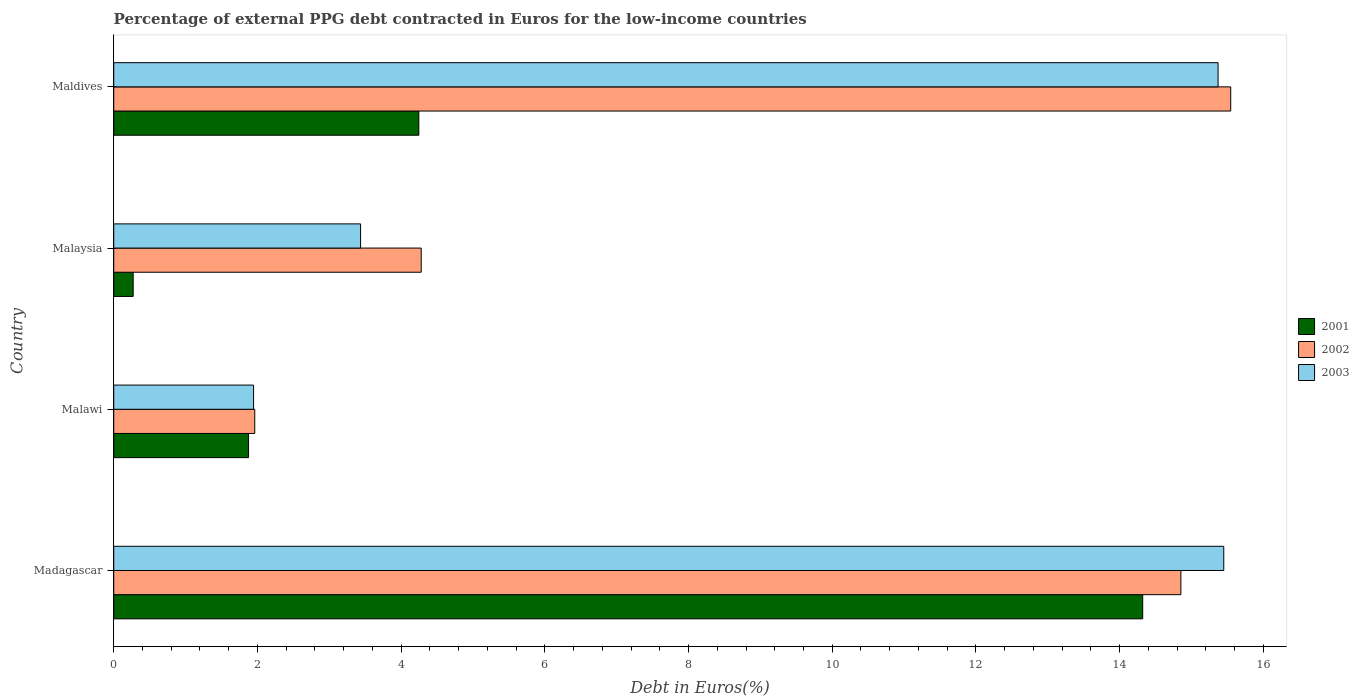How many different coloured bars are there?
Provide a short and direct response. 3. How many groups of bars are there?
Your answer should be very brief. 4. Are the number of bars on each tick of the Y-axis equal?
Your answer should be compact. Yes. How many bars are there on the 4th tick from the top?
Your answer should be very brief. 3. How many bars are there on the 2nd tick from the bottom?
Your response must be concise. 3. What is the label of the 1st group of bars from the top?
Keep it short and to the point. Maldives. In how many cases, is the number of bars for a given country not equal to the number of legend labels?
Ensure brevity in your answer.  0. What is the percentage of external PPG debt contracted in Euros in 2001 in Maldives?
Keep it short and to the point. 4.25. Across all countries, what is the maximum percentage of external PPG debt contracted in Euros in 2003?
Provide a succinct answer. 15.45. Across all countries, what is the minimum percentage of external PPG debt contracted in Euros in 2001?
Provide a short and direct response. 0.27. In which country was the percentage of external PPG debt contracted in Euros in 2003 maximum?
Offer a terse response. Madagascar. In which country was the percentage of external PPG debt contracted in Euros in 2002 minimum?
Your answer should be very brief. Malawi. What is the total percentage of external PPG debt contracted in Euros in 2001 in the graph?
Provide a short and direct response. 20.71. What is the difference between the percentage of external PPG debt contracted in Euros in 2002 in Malawi and that in Maldives?
Ensure brevity in your answer.  -13.58. What is the difference between the percentage of external PPG debt contracted in Euros in 2002 in Malawi and the percentage of external PPG debt contracted in Euros in 2003 in Madagascar?
Keep it short and to the point. -13.49. What is the average percentage of external PPG debt contracted in Euros in 2003 per country?
Keep it short and to the point. 9.05. What is the difference between the percentage of external PPG debt contracted in Euros in 2001 and percentage of external PPG debt contracted in Euros in 2003 in Malawi?
Provide a succinct answer. -0.07. What is the ratio of the percentage of external PPG debt contracted in Euros in 2003 in Malawi to that in Maldives?
Your answer should be very brief. 0.13. Is the percentage of external PPG debt contracted in Euros in 2001 in Madagascar less than that in Maldives?
Offer a very short reply. No. What is the difference between the highest and the second highest percentage of external PPG debt contracted in Euros in 2001?
Provide a short and direct response. 10.07. What is the difference between the highest and the lowest percentage of external PPG debt contracted in Euros in 2001?
Your answer should be compact. 14.05. Is the sum of the percentage of external PPG debt contracted in Euros in 2002 in Madagascar and Malaysia greater than the maximum percentage of external PPG debt contracted in Euros in 2003 across all countries?
Offer a very short reply. Yes. What does the 2nd bar from the top in Maldives represents?
Provide a short and direct response. 2002. Are all the bars in the graph horizontal?
Your answer should be very brief. Yes. How many countries are there in the graph?
Ensure brevity in your answer.  4. Are the values on the major ticks of X-axis written in scientific E-notation?
Offer a terse response. No. Does the graph contain any zero values?
Offer a very short reply. No. Does the graph contain grids?
Provide a short and direct response. No. How many legend labels are there?
Keep it short and to the point. 3. How are the legend labels stacked?
Provide a short and direct response. Vertical. What is the title of the graph?
Ensure brevity in your answer.  Percentage of external PPG debt contracted in Euros for the low-income countries. What is the label or title of the X-axis?
Ensure brevity in your answer.  Debt in Euros(%). What is the label or title of the Y-axis?
Offer a very short reply. Country. What is the Debt in Euros(%) of 2001 in Madagascar?
Ensure brevity in your answer.  14.32. What is the Debt in Euros(%) in 2002 in Madagascar?
Offer a very short reply. 14.85. What is the Debt in Euros(%) in 2003 in Madagascar?
Offer a very short reply. 15.45. What is the Debt in Euros(%) of 2001 in Malawi?
Provide a short and direct response. 1.88. What is the Debt in Euros(%) of 2002 in Malawi?
Keep it short and to the point. 1.96. What is the Debt in Euros(%) in 2003 in Malawi?
Ensure brevity in your answer.  1.95. What is the Debt in Euros(%) in 2001 in Malaysia?
Ensure brevity in your answer.  0.27. What is the Debt in Euros(%) in 2002 in Malaysia?
Make the answer very short. 4.28. What is the Debt in Euros(%) of 2003 in Malaysia?
Keep it short and to the point. 3.44. What is the Debt in Euros(%) in 2001 in Maldives?
Make the answer very short. 4.25. What is the Debt in Euros(%) in 2002 in Maldives?
Your answer should be compact. 15.55. What is the Debt in Euros(%) in 2003 in Maldives?
Offer a terse response. 15.37. Across all countries, what is the maximum Debt in Euros(%) in 2001?
Keep it short and to the point. 14.32. Across all countries, what is the maximum Debt in Euros(%) of 2002?
Your answer should be very brief. 15.55. Across all countries, what is the maximum Debt in Euros(%) in 2003?
Offer a very short reply. 15.45. Across all countries, what is the minimum Debt in Euros(%) of 2001?
Provide a short and direct response. 0.27. Across all countries, what is the minimum Debt in Euros(%) of 2002?
Provide a succinct answer. 1.96. Across all countries, what is the minimum Debt in Euros(%) of 2003?
Give a very brief answer. 1.95. What is the total Debt in Euros(%) in 2001 in the graph?
Give a very brief answer. 20.71. What is the total Debt in Euros(%) of 2002 in the graph?
Your answer should be very brief. 36.64. What is the total Debt in Euros(%) of 2003 in the graph?
Offer a terse response. 36.2. What is the difference between the Debt in Euros(%) of 2001 in Madagascar and that in Malawi?
Give a very brief answer. 12.44. What is the difference between the Debt in Euros(%) in 2002 in Madagascar and that in Malawi?
Give a very brief answer. 12.89. What is the difference between the Debt in Euros(%) in 2003 in Madagascar and that in Malawi?
Keep it short and to the point. 13.5. What is the difference between the Debt in Euros(%) of 2001 in Madagascar and that in Malaysia?
Ensure brevity in your answer.  14.05. What is the difference between the Debt in Euros(%) in 2002 in Madagascar and that in Malaysia?
Provide a succinct answer. 10.57. What is the difference between the Debt in Euros(%) in 2003 in Madagascar and that in Malaysia?
Your answer should be compact. 12.01. What is the difference between the Debt in Euros(%) of 2001 in Madagascar and that in Maldives?
Give a very brief answer. 10.07. What is the difference between the Debt in Euros(%) of 2002 in Madagascar and that in Maldives?
Your response must be concise. -0.69. What is the difference between the Debt in Euros(%) in 2003 in Madagascar and that in Maldives?
Keep it short and to the point. 0.08. What is the difference between the Debt in Euros(%) of 2001 in Malawi and that in Malaysia?
Your answer should be compact. 1.61. What is the difference between the Debt in Euros(%) of 2002 in Malawi and that in Malaysia?
Your response must be concise. -2.32. What is the difference between the Debt in Euros(%) of 2003 in Malawi and that in Malaysia?
Your answer should be compact. -1.49. What is the difference between the Debt in Euros(%) of 2001 in Malawi and that in Maldives?
Ensure brevity in your answer.  -2.37. What is the difference between the Debt in Euros(%) of 2002 in Malawi and that in Maldives?
Provide a short and direct response. -13.58. What is the difference between the Debt in Euros(%) of 2003 in Malawi and that in Maldives?
Provide a short and direct response. -13.42. What is the difference between the Debt in Euros(%) of 2001 in Malaysia and that in Maldives?
Offer a very short reply. -3.98. What is the difference between the Debt in Euros(%) in 2002 in Malaysia and that in Maldives?
Offer a terse response. -11.27. What is the difference between the Debt in Euros(%) of 2003 in Malaysia and that in Maldives?
Offer a very short reply. -11.93. What is the difference between the Debt in Euros(%) in 2001 in Madagascar and the Debt in Euros(%) in 2002 in Malawi?
Your response must be concise. 12.36. What is the difference between the Debt in Euros(%) of 2001 in Madagascar and the Debt in Euros(%) of 2003 in Malawi?
Your answer should be compact. 12.37. What is the difference between the Debt in Euros(%) of 2002 in Madagascar and the Debt in Euros(%) of 2003 in Malawi?
Provide a succinct answer. 12.91. What is the difference between the Debt in Euros(%) of 2001 in Madagascar and the Debt in Euros(%) of 2002 in Malaysia?
Provide a short and direct response. 10.04. What is the difference between the Debt in Euros(%) of 2001 in Madagascar and the Debt in Euros(%) of 2003 in Malaysia?
Your answer should be very brief. 10.89. What is the difference between the Debt in Euros(%) of 2002 in Madagascar and the Debt in Euros(%) of 2003 in Malaysia?
Make the answer very short. 11.42. What is the difference between the Debt in Euros(%) of 2001 in Madagascar and the Debt in Euros(%) of 2002 in Maldives?
Provide a succinct answer. -1.22. What is the difference between the Debt in Euros(%) of 2001 in Madagascar and the Debt in Euros(%) of 2003 in Maldives?
Your answer should be compact. -1.05. What is the difference between the Debt in Euros(%) of 2002 in Madagascar and the Debt in Euros(%) of 2003 in Maldives?
Give a very brief answer. -0.52. What is the difference between the Debt in Euros(%) of 2001 in Malawi and the Debt in Euros(%) of 2002 in Malaysia?
Your answer should be very brief. -2.4. What is the difference between the Debt in Euros(%) of 2001 in Malawi and the Debt in Euros(%) of 2003 in Malaysia?
Offer a very short reply. -1.56. What is the difference between the Debt in Euros(%) in 2002 in Malawi and the Debt in Euros(%) in 2003 in Malaysia?
Keep it short and to the point. -1.47. What is the difference between the Debt in Euros(%) in 2001 in Malawi and the Debt in Euros(%) in 2002 in Maldives?
Offer a very short reply. -13.67. What is the difference between the Debt in Euros(%) in 2001 in Malawi and the Debt in Euros(%) in 2003 in Maldives?
Your answer should be compact. -13.49. What is the difference between the Debt in Euros(%) of 2002 in Malawi and the Debt in Euros(%) of 2003 in Maldives?
Provide a succinct answer. -13.41. What is the difference between the Debt in Euros(%) of 2001 in Malaysia and the Debt in Euros(%) of 2002 in Maldives?
Provide a short and direct response. -15.28. What is the difference between the Debt in Euros(%) of 2001 in Malaysia and the Debt in Euros(%) of 2003 in Maldives?
Give a very brief answer. -15.1. What is the difference between the Debt in Euros(%) in 2002 in Malaysia and the Debt in Euros(%) in 2003 in Maldives?
Provide a succinct answer. -11.09. What is the average Debt in Euros(%) in 2001 per country?
Your answer should be compact. 5.18. What is the average Debt in Euros(%) in 2002 per country?
Your answer should be very brief. 9.16. What is the average Debt in Euros(%) in 2003 per country?
Provide a short and direct response. 9.05. What is the difference between the Debt in Euros(%) in 2001 and Debt in Euros(%) in 2002 in Madagascar?
Provide a short and direct response. -0.53. What is the difference between the Debt in Euros(%) in 2001 and Debt in Euros(%) in 2003 in Madagascar?
Keep it short and to the point. -1.13. What is the difference between the Debt in Euros(%) in 2002 and Debt in Euros(%) in 2003 in Madagascar?
Keep it short and to the point. -0.6. What is the difference between the Debt in Euros(%) of 2001 and Debt in Euros(%) of 2002 in Malawi?
Provide a succinct answer. -0.09. What is the difference between the Debt in Euros(%) in 2001 and Debt in Euros(%) in 2003 in Malawi?
Your response must be concise. -0.07. What is the difference between the Debt in Euros(%) of 2002 and Debt in Euros(%) of 2003 in Malawi?
Give a very brief answer. 0.02. What is the difference between the Debt in Euros(%) of 2001 and Debt in Euros(%) of 2002 in Malaysia?
Your answer should be compact. -4.01. What is the difference between the Debt in Euros(%) in 2001 and Debt in Euros(%) in 2003 in Malaysia?
Provide a succinct answer. -3.16. What is the difference between the Debt in Euros(%) in 2002 and Debt in Euros(%) in 2003 in Malaysia?
Your response must be concise. 0.84. What is the difference between the Debt in Euros(%) in 2001 and Debt in Euros(%) in 2002 in Maldives?
Your answer should be very brief. -11.3. What is the difference between the Debt in Euros(%) in 2001 and Debt in Euros(%) in 2003 in Maldives?
Offer a terse response. -11.12. What is the difference between the Debt in Euros(%) of 2002 and Debt in Euros(%) of 2003 in Maldives?
Provide a succinct answer. 0.18. What is the ratio of the Debt in Euros(%) of 2001 in Madagascar to that in Malawi?
Ensure brevity in your answer.  7.63. What is the ratio of the Debt in Euros(%) of 2002 in Madagascar to that in Malawi?
Your answer should be very brief. 7.57. What is the ratio of the Debt in Euros(%) of 2003 in Madagascar to that in Malawi?
Keep it short and to the point. 7.94. What is the ratio of the Debt in Euros(%) in 2001 in Madagascar to that in Malaysia?
Give a very brief answer. 52.92. What is the ratio of the Debt in Euros(%) in 2002 in Madagascar to that in Malaysia?
Give a very brief answer. 3.47. What is the ratio of the Debt in Euros(%) in 2003 in Madagascar to that in Malaysia?
Make the answer very short. 4.5. What is the ratio of the Debt in Euros(%) in 2001 in Madagascar to that in Maldives?
Offer a very short reply. 3.37. What is the ratio of the Debt in Euros(%) in 2002 in Madagascar to that in Maldives?
Give a very brief answer. 0.96. What is the ratio of the Debt in Euros(%) of 2001 in Malawi to that in Malaysia?
Offer a very short reply. 6.93. What is the ratio of the Debt in Euros(%) of 2002 in Malawi to that in Malaysia?
Give a very brief answer. 0.46. What is the ratio of the Debt in Euros(%) of 2003 in Malawi to that in Malaysia?
Keep it short and to the point. 0.57. What is the ratio of the Debt in Euros(%) in 2001 in Malawi to that in Maldives?
Your answer should be compact. 0.44. What is the ratio of the Debt in Euros(%) of 2002 in Malawi to that in Maldives?
Keep it short and to the point. 0.13. What is the ratio of the Debt in Euros(%) in 2003 in Malawi to that in Maldives?
Offer a very short reply. 0.13. What is the ratio of the Debt in Euros(%) in 2001 in Malaysia to that in Maldives?
Keep it short and to the point. 0.06. What is the ratio of the Debt in Euros(%) in 2002 in Malaysia to that in Maldives?
Provide a succinct answer. 0.28. What is the ratio of the Debt in Euros(%) of 2003 in Malaysia to that in Maldives?
Your response must be concise. 0.22. What is the difference between the highest and the second highest Debt in Euros(%) in 2001?
Give a very brief answer. 10.07. What is the difference between the highest and the second highest Debt in Euros(%) of 2002?
Your response must be concise. 0.69. What is the difference between the highest and the second highest Debt in Euros(%) in 2003?
Offer a very short reply. 0.08. What is the difference between the highest and the lowest Debt in Euros(%) of 2001?
Your answer should be very brief. 14.05. What is the difference between the highest and the lowest Debt in Euros(%) in 2002?
Provide a short and direct response. 13.58. What is the difference between the highest and the lowest Debt in Euros(%) in 2003?
Make the answer very short. 13.5. 